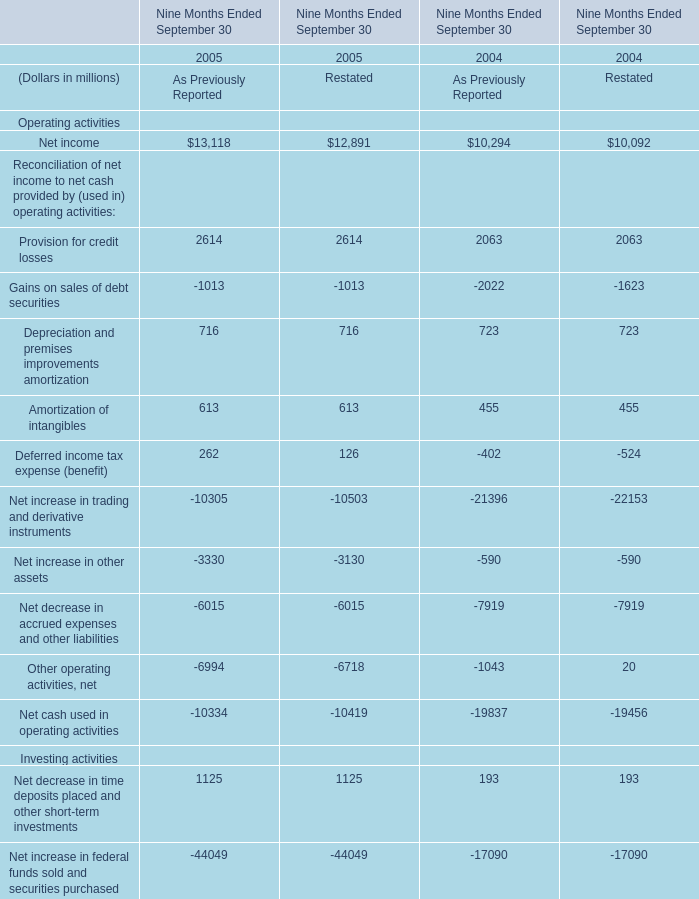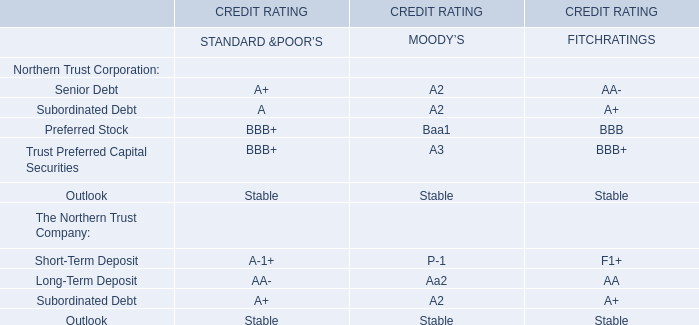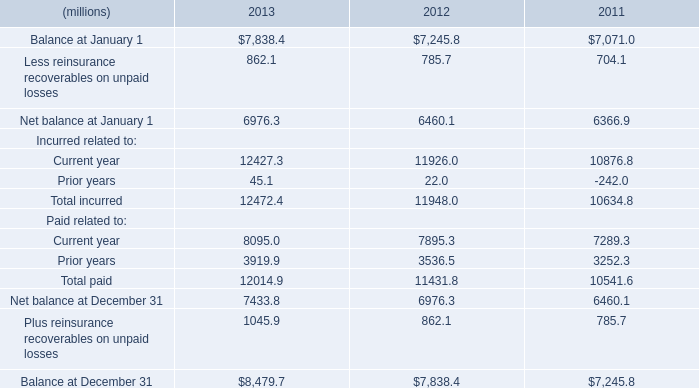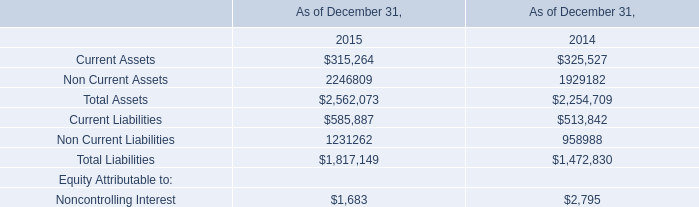What is the sum of Non Current Assets of As of December 31, 2015, and Net balance at January 1 of 2013 ? 
Computations: (2246809.0 + 6976.3)
Answer: 2253785.3. 